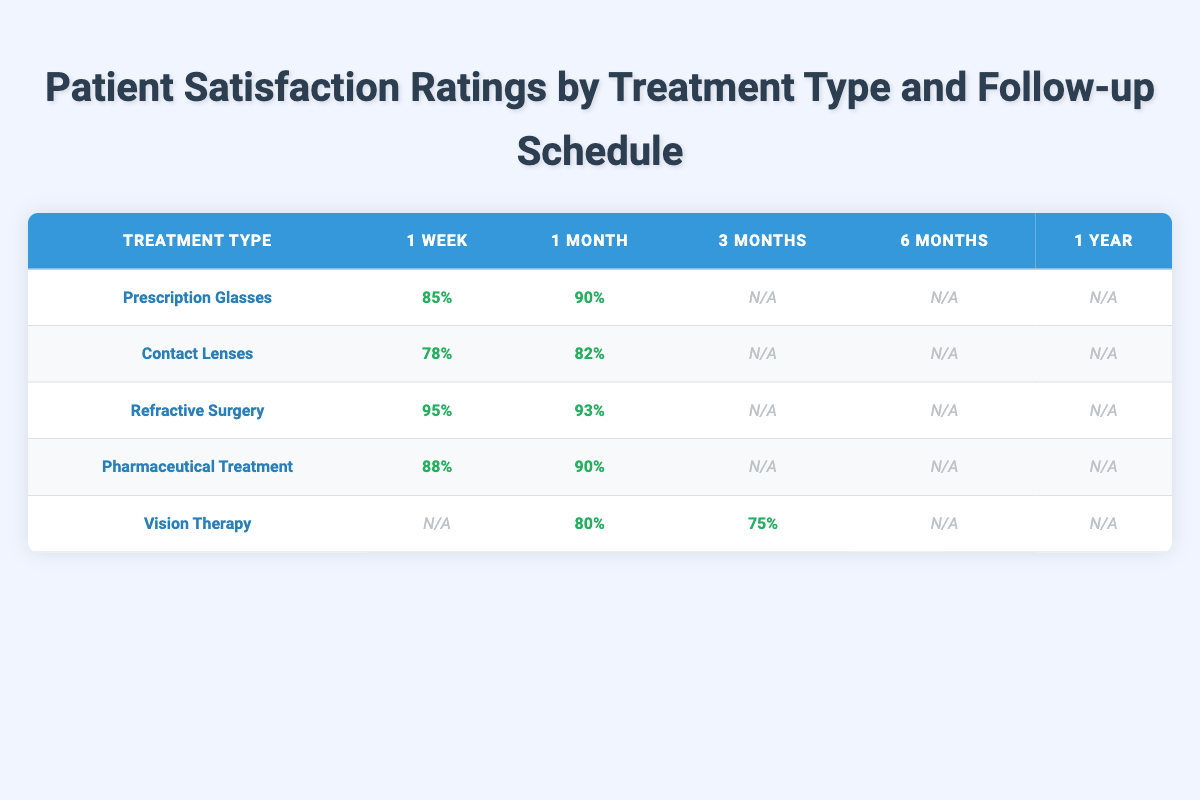What is the satisfaction rating for Prescription Glasses at the 1 month follow-up? The table shows that the satisfaction rating for Prescription Glasses at the 1 month follow-up is 90%.
Answer: 90% What is the highest satisfaction rating for any treatment type? By reviewing all the ratings in the table, the highest satisfaction rating is 95% for Refractive Surgery at the 1 week follow-up.
Answer: 95% Are there any treatments with a satisfaction rating at the 6 month follow-up? The table indicates that there are no treatments with satisfaction ratings at the 6 month follow-up, as all entries are listed as N/A (not applicable).
Answer: No Which treatment type has a satisfaction rating of 75% and at what follow-up period? The data reveals that Vision Therapy has a satisfaction rating of 75% at the 3 months follow-up.
Answer: Vision Therapy, 3 months What is the difference in satisfaction ratings between Contact Lenses and Pharmaceutical Treatment at the 1 week follow-up? The satisfaction rating for Contact Lenses at the 1 week follow-up is 78%, while for Pharmaceutical Treatment, it is 88%. The difference is 88% - 78% = 10%.
Answer: 10% Is the satisfaction rating for Vision Therapy at the 1 month follow-up greater than 80%? The rating for Vision Therapy at the 1 month follow-up is 80%, which means it is not greater than 80%.
Answer: No What is the average satisfaction rating for Refractive Surgery across all follow-up periods listed? The ratings for Refractive Surgery are 95% at 1 week and 93% at 1 month. The average is (95 + 93) / 2 = 94%.
Answer: 94% Which treatment type has the lowest satisfaction rating and what is it? Examining the table shows that Contact Lenses have the lowest satisfaction rating at 78% for the 1 week follow-up.
Answer: Contact Lenses, 78% 